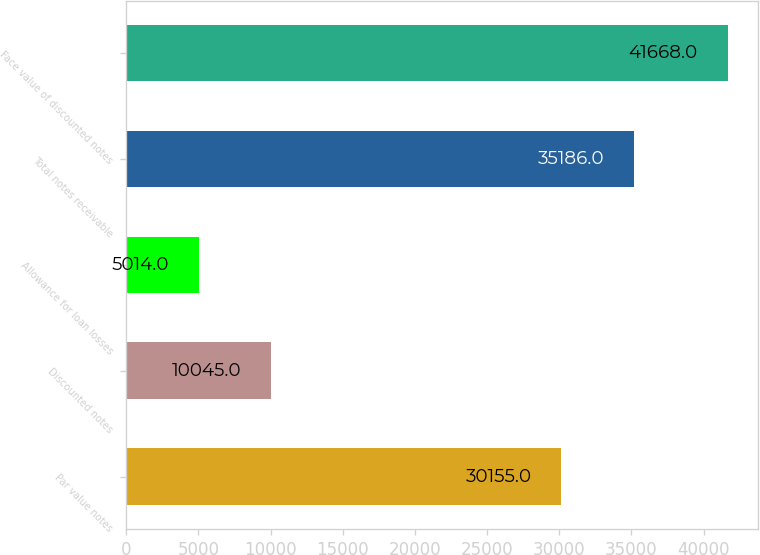Convert chart. <chart><loc_0><loc_0><loc_500><loc_500><bar_chart><fcel>Par value notes<fcel>Discounted notes<fcel>Allowance for loan losses<fcel>Total notes receivable<fcel>Face value of discounted notes<nl><fcel>30155<fcel>10045<fcel>5014<fcel>35186<fcel>41668<nl></chart> 